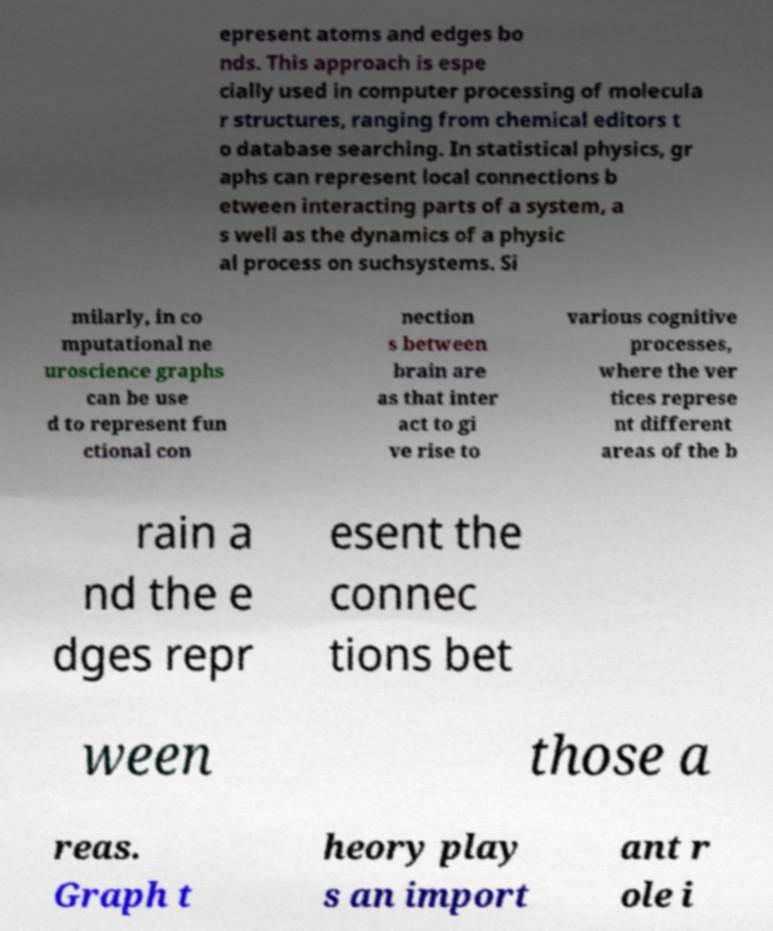Can you read and provide the text displayed in the image?This photo seems to have some interesting text. Can you extract and type it out for me? epresent atoms and edges bo nds. This approach is espe cially used in computer processing of molecula r structures, ranging from chemical editors t o database searching. In statistical physics, gr aphs can represent local connections b etween interacting parts of a system, a s well as the dynamics of a physic al process on suchsystems. Si milarly, in co mputational ne uroscience graphs can be use d to represent fun ctional con nection s between brain are as that inter act to gi ve rise to various cognitive processes, where the ver tices represe nt different areas of the b rain a nd the e dges repr esent the connec tions bet ween those a reas. Graph t heory play s an import ant r ole i 